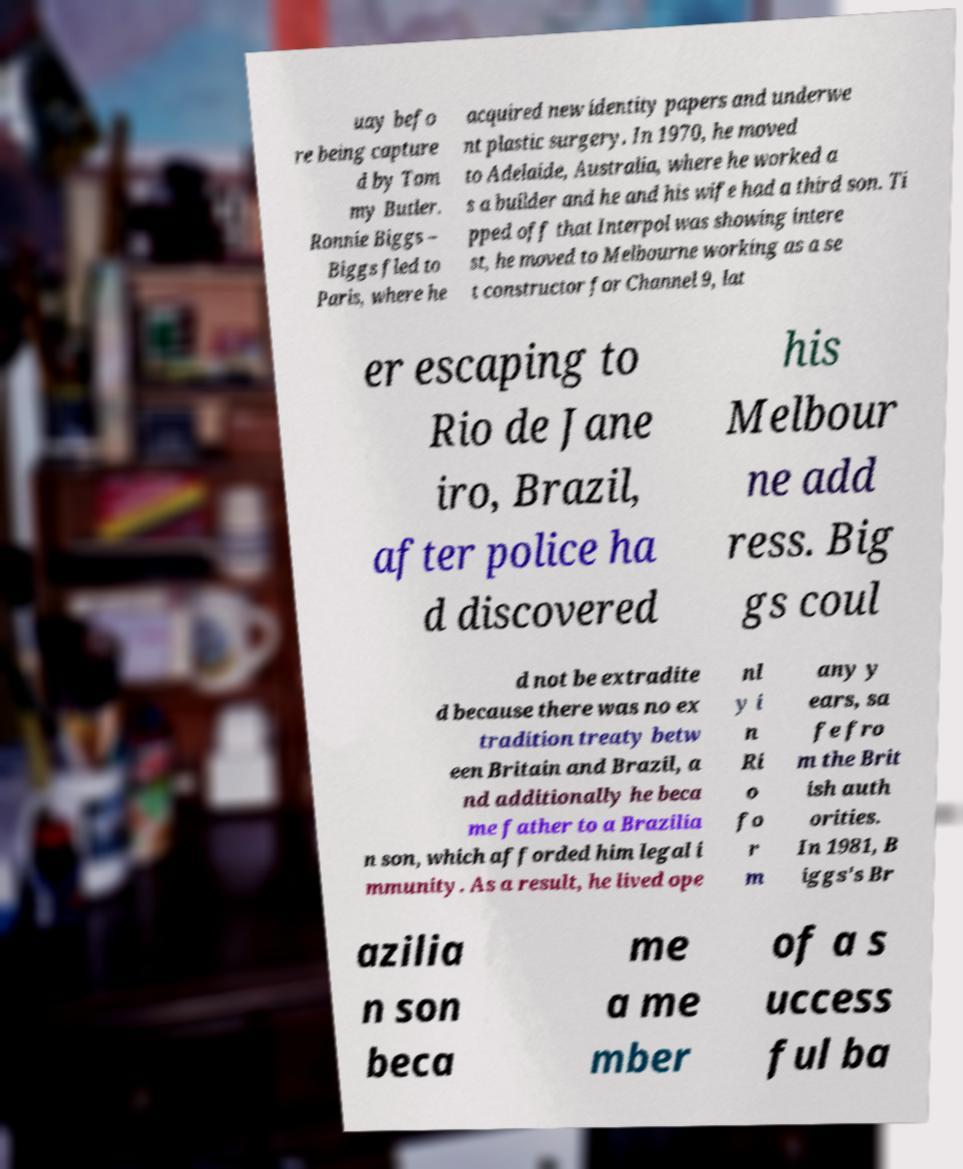There's text embedded in this image that I need extracted. Can you transcribe it verbatim? uay befo re being capture d by Tom my Butler. Ronnie Biggs – Biggs fled to Paris, where he acquired new identity papers and underwe nt plastic surgery. In 1970, he moved to Adelaide, Australia, where he worked a s a builder and he and his wife had a third son. Ti pped off that Interpol was showing intere st, he moved to Melbourne working as a se t constructor for Channel 9, lat er escaping to Rio de Jane iro, Brazil, after police ha d discovered his Melbour ne add ress. Big gs coul d not be extradite d because there was no ex tradition treaty betw een Britain and Brazil, a nd additionally he beca me father to a Brazilia n son, which afforded him legal i mmunity. As a result, he lived ope nl y i n Ri o fo r m any y ears, sa fe fro m the Brit ish auth orities. In 1981, B iggs's Br azilia n son beca me a me mber of a s uccess ful ba 